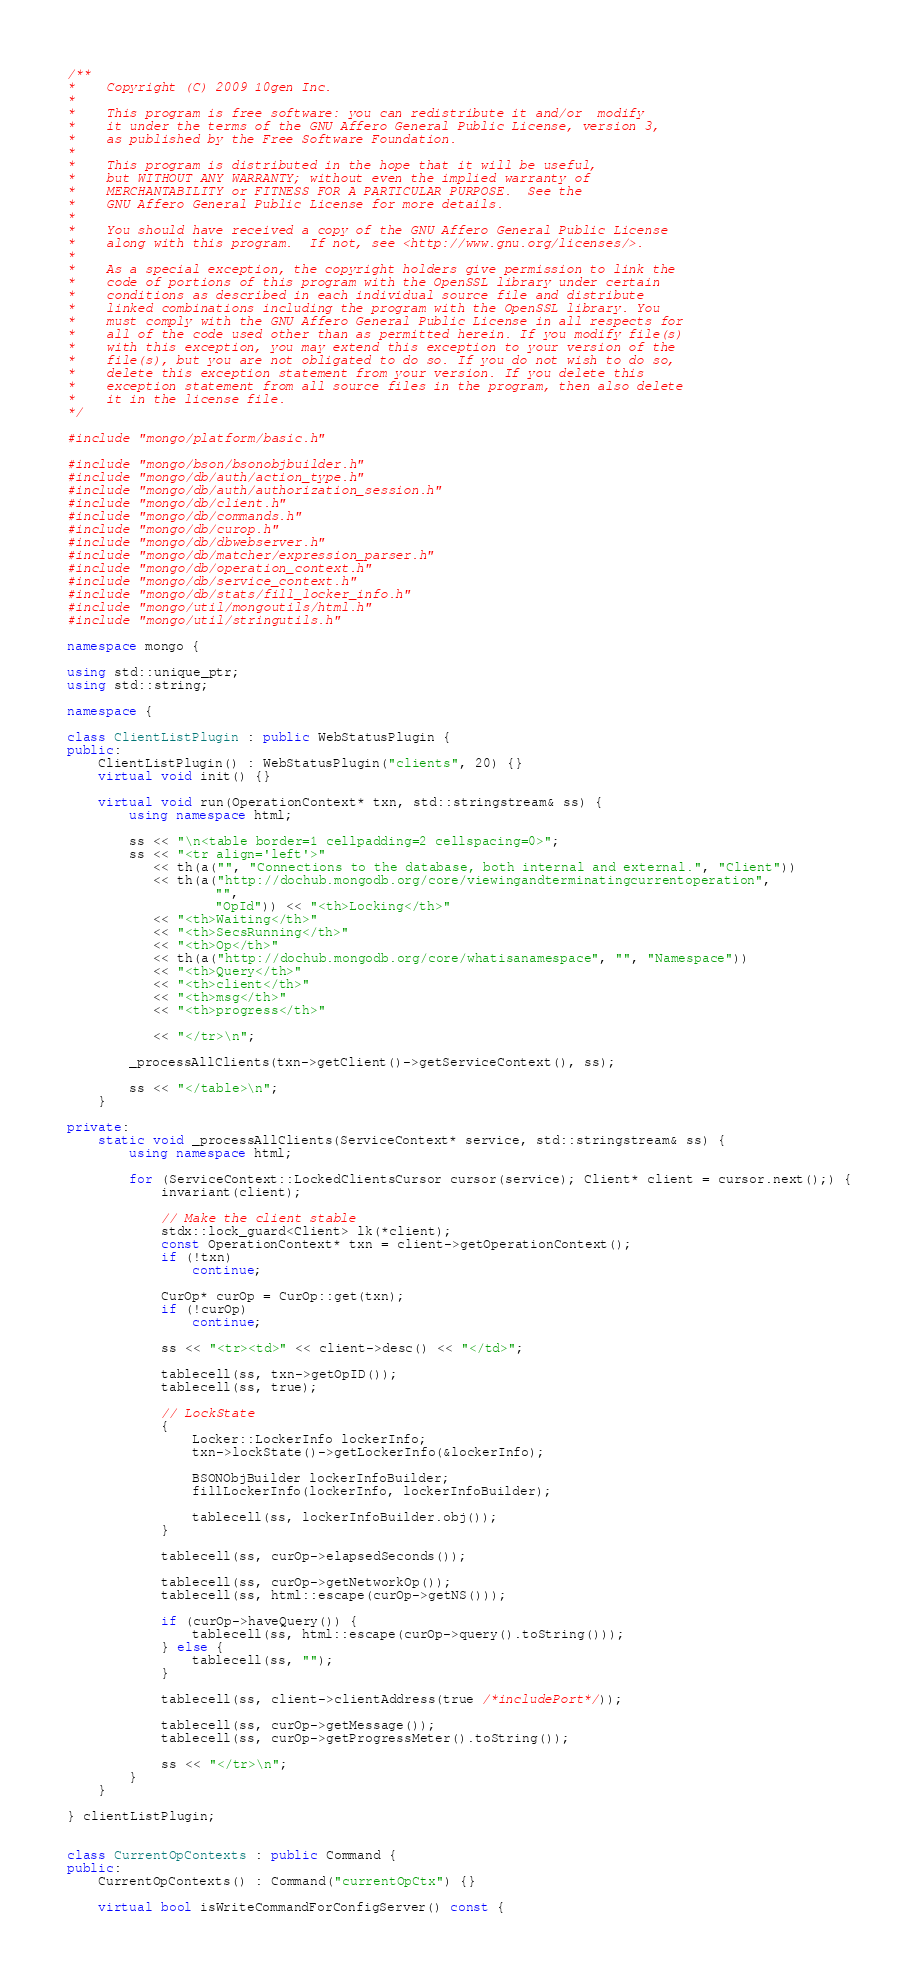<code> <loc_0><loc_0><loc_500><loc_500><_C++_>/**
*    Copyright (C) 2009 10gen Inc.
*
*    This program is free software: you can redistribute it and/or  modify
*    it under the terms of the GNU Affero General Public License, version 3,
*    as published by the Free Software Foundation.
*
*    This program is distributed in the hope that it will be useful,
*    but WITHOUT ANY WARRANTY; without even the implied warranty of
*    MERCHANTABILITY or FITNESS FOR A PARTICULAR PURPOSE.  See the
*    GNU Affero General Public License for more details.
*
*    You should have received a copy of the GNU Affero General Public License
*    along with this program.  If not, see <http://www.gnu.org/licenses/>.
*
*    As a special exception, the copyright holders give permission to link the
*    code of portions of this program with the OpenSSL library under certain
*    conditions as described in each individual source file and distribute
*    linked combinations including the program with the OpenSSL library. You
*    must comply with the GNU Affero General Public License in all respects for
*    all of the code used other than as permitted herein. If you modify file(s)
*    with this exception, you may extend this exception to your version of the
*    file(s), but you are not obligated to do so. If you do not wish to do so,
*    delete this exception statement from your version. If you delete this
*    exception statement from all source files in the program, then also delete
*    it in the license file.
*/

#include "mongo/platform/basic.h"

#include "mongo/bson/bsonobjbuilder.h"
#include "mongo/db/auth/action_type.h"
#include "mongo/db/auth/authorization_session.h"
#include "mongo/db/client.h"
#include "mongo/db/commands.h"
#include "mongo/db/curop.h"
#include "mongo/db/dbwebserver.h"
#include "mongo/db/matcher/expression_parser.h"
#include "mongo/db/operation_context.h"
#include "mongo/db/service_context.h"
#include "mongo/db/stats/fill_locker_info.h"
#include "mongo/util/mongoutils/html.h"
#include "mongo/util/stringutils.h"

namespace mongo {

using std::unique_ptr;
using std::string;

namespace {

class ClientListPlugin : public WebStatusPlugin {
public:
    ClientListPlugin() : WebStatusPlugin("clients", 20) {}
    virtual void init() {}

    virtual void run(OperationContext* txn, std::stringstream& ss) {
        using namespace html;

        ss << "\n<table border=1 cellpadding=2 cellspacing=0>";
        ss << "<tr align='left'>"
           << th(a("", "Connections to the database, both internal and external.", "Client"))
           << th(a("http://dochub.mongodb.org/core/viewingandterminatingcurrentoperation",
                   "",
                   "OpId")) << "<th>Locking</th>"
           << "<th>Waiting</th>"
           << "<th>SecsRunning</th>"
           << "<th>Op</th>"
           << th(a("http://dochub.mongodb.org/core/whatisanamespace", "", "Namespace"))
           << "<th>Query</th>"
           << "<th>client</th>"
           << "<th>msg</th>"
           << "<th>progress</th>"

           << "</tr>\n";

        _processAllClients(txn->getClient()->getServiceContext(), ss);

        ss << "</table>\n";
    }

private:
    static void _processAllClients(ServiceContext* service, std::stringstream& ss) {
        using namespace html;

        for (ServiceContext::LockedClientsCursor cursor(service); Client* client = cursor.next();) {
            invariant(client);

            // Make the client stable
            stdx::lock_guard<Client> lk(*client);
            const OperationContext* txn = client->getOperationContext();
            if (!txn)
                continue;

            CurOp* curOp = CurOp::get(txn);
            if (!curOp)
                continue;

            ss << "<tr><td>" << client->desc() << "</td>";

            tablecell(ss, txn->getOpID());
            tablecell(ss, true);

            // LockState
            {
                Locker::LockerInfo lockerInfo;
                txn->lockState()->getLockerInfo(&lockerInfo);

                BSONObjBuilder lockerInfoBuilder;
                fillLockerInfo(lockerInfo, lockerInfoBuilder);

                tablecell(ss, lockerInfoBuilder.obj());
            }

            tablecell(ss, curOp->elapsedSeconds());

            tablecell(ss, curOp->getNetworkOp());
            tablecell(ss, html::escape(curOp->getNS()));

            if (curOp->haveQuery()) {
                tablecell(ss, html::escape(curOp->query().toString()));
            } else {
                tablecell(ss, "");
            }

            tablecell(ss, client->clientAddress(true /*includePort*/));

            tablecell(ss, curOp->getMessage());
            tablecell(ss, curOp->getProgressMeter().toString());

            ss << "</tr>\n";
        }
    }

} clientListPlugin;


class CurrentOpContexts : public Command {
public:
    CurrentOpContexts() : Command("currentOpCtx") {}

    virtual bool isWriteCommandForConfigServer() const {</code> 